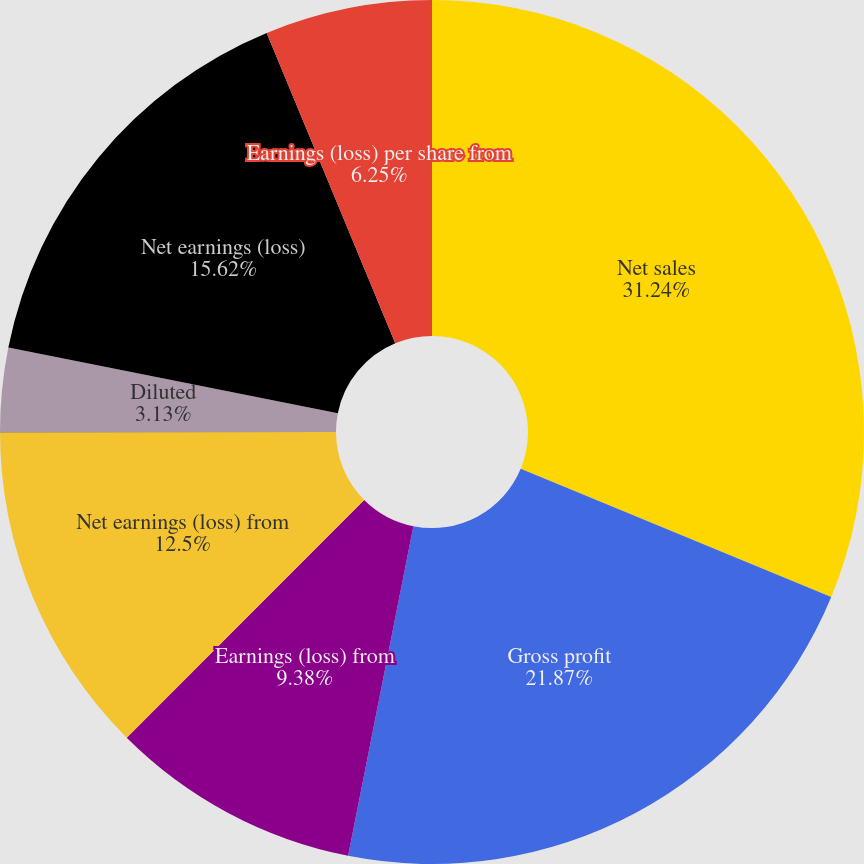Convert chart. <chart><loc_0><loc_0><loc_500><loc_500><pie_chart><fcel>Net sales<fcel>Gross profit<fcel>Earnings (loss) from<fcel>Net earnings (loss) from<fcel>Basic<fcel>Diluted<fcel>Net earnings (loss)<fcel>Earnings (loss) per share from<nl><fcel>31.24%<fcel>21.87%<fcel>9.38%<fcel>12.5%<fcel>0.01%<fcel>3.13%<fcel>15.62%<fcel>6.25%<nl></chart> 